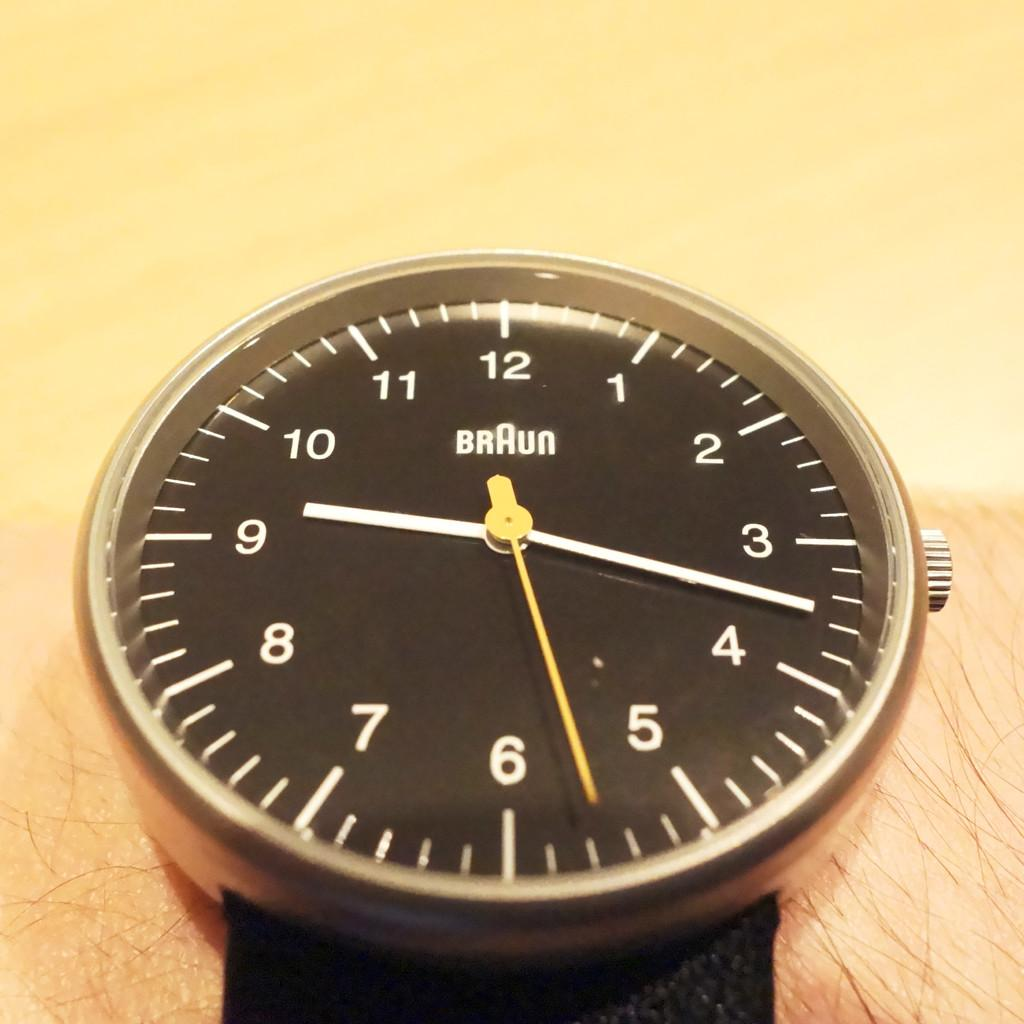Provide a one-sentence caption for the provided image. A Braun watch face is shown with the hands pointing to 9:17. 